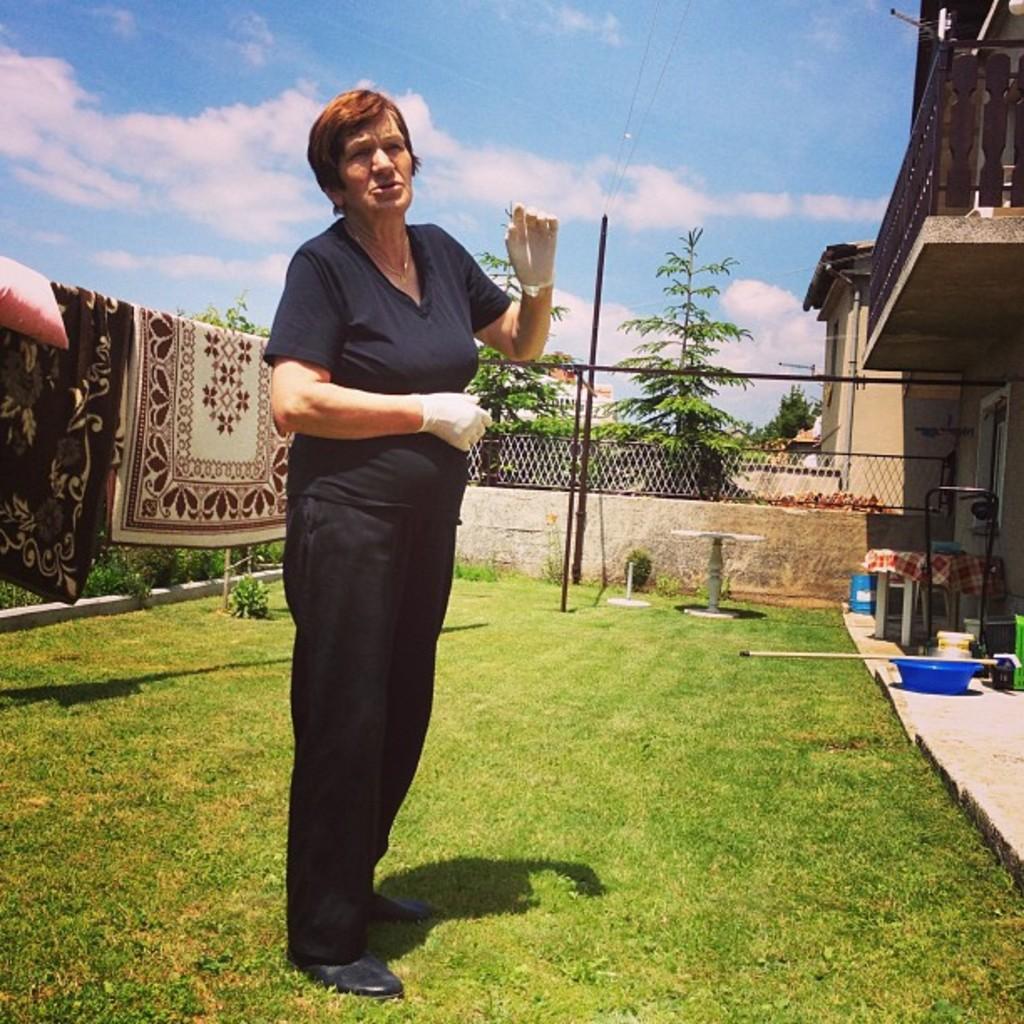Could you give a brief overview of what you see in this image? In this picture I can see a woman standing she wore gloves to her hands and I can see trees and buildings and couple of blankets and a pillow and a metal fence and i can see a bucket and a tub and a mopping stick and i can see a chair and a table and grass on the ground and few plants. 